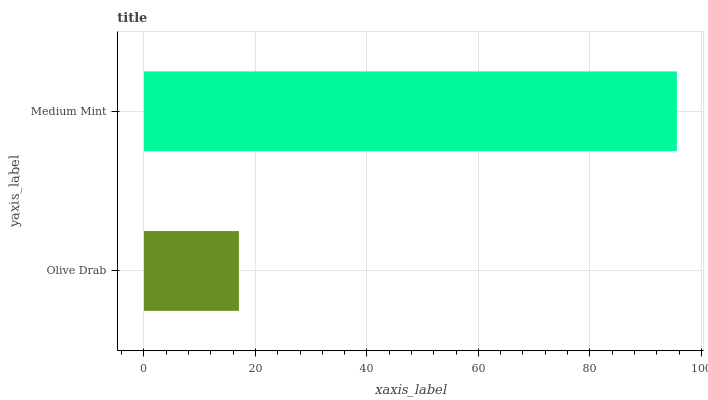Is Olive Drab the minimum?
Answer yes or no. Yes. Is Medium Mint the maximum?
Answer yes or no. Yes. Is Medium Mint the minimum?
Answer yes or no. No. Is Medium Mint greater than Olive Drab?
Answer yes or no. Yes. Is Olive Drab less than Medium Mint?
Answer yes or no. Yes. Is Olive Drab greater than Medium Mint?
Answer yes or no. No. Is Medium Mint less than Olive Drab?
Answer yes or no. No. Is Medium Mint the high median?
Answer yes or no. Yes. Is Olive Drab the low median?
Answer yes or no. Yes. Is Olive Drab the high median?
Answer yes or no. No. Is Medium Mint the low median?
Answer yes or no. No. 